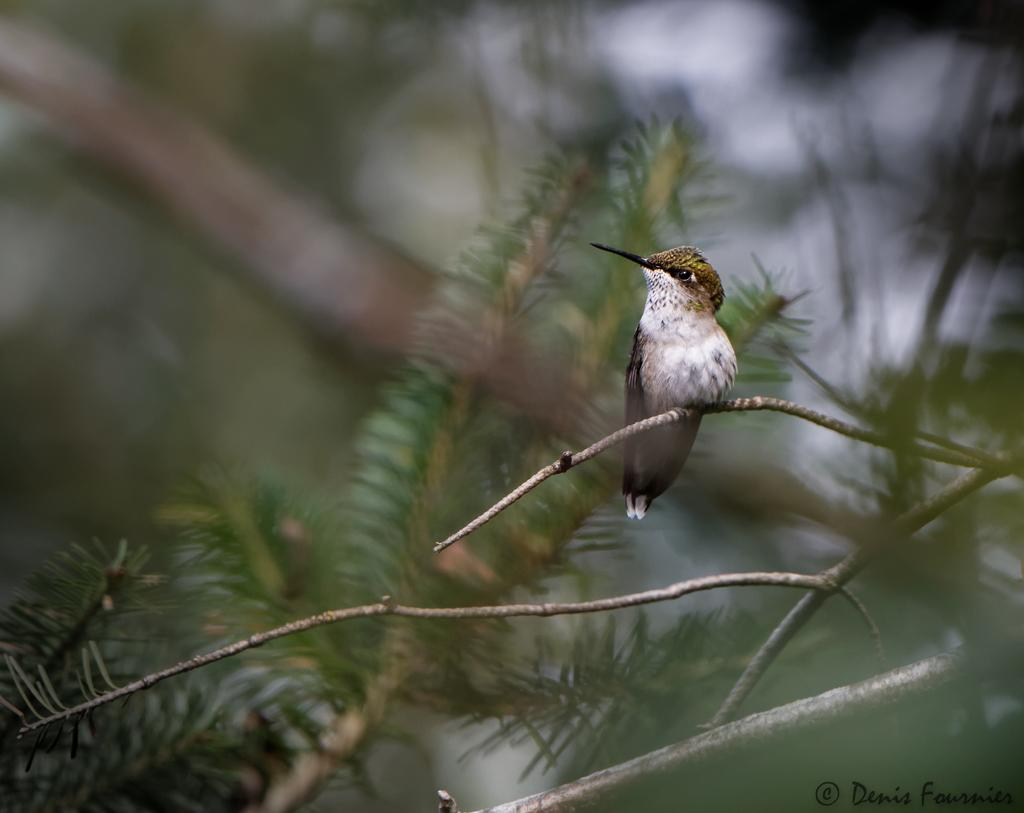What type of animal is in the image? There is a bird in the image. Where is the bird located? The bird is standing on a branch. What is the branch a part of? The branch is part of a tree. What type of ice is covering the bird in the image? There is no ice present in the image; the bird is standing on a branch of a tree. 